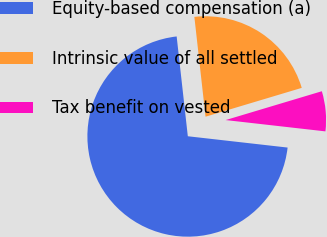Convert chart. <chart><loc_0><loc_0><loc_500><loc_500><pie_chart><fcel>Equity-based compensation (a)<fcel>Intrinsic value of all settled<fcel>Tax benefit on vested<nl><fcel>71.43%<fcel>22.14%<fcel>6.43%<nl></chart> 